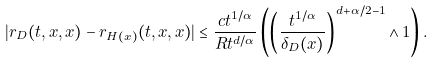Convert formula to latex. <formula><loc_0><loc_0><loc_500><loc_500>| r _ { D } ( t , x , x ) - r _ { H ( x ) } ( t , x , x ) | \leq \frac { c t ^ { 1 / \alpha } } { R t ^ { d / \alpha } } \left ( \left ( \frac { t ^ { 1 / \alpha } } { \delta _ { D } ( x ) } \right ) ^ { d + \alpha / 2 - 1 } \wedge 1 \right ) .</formula> 